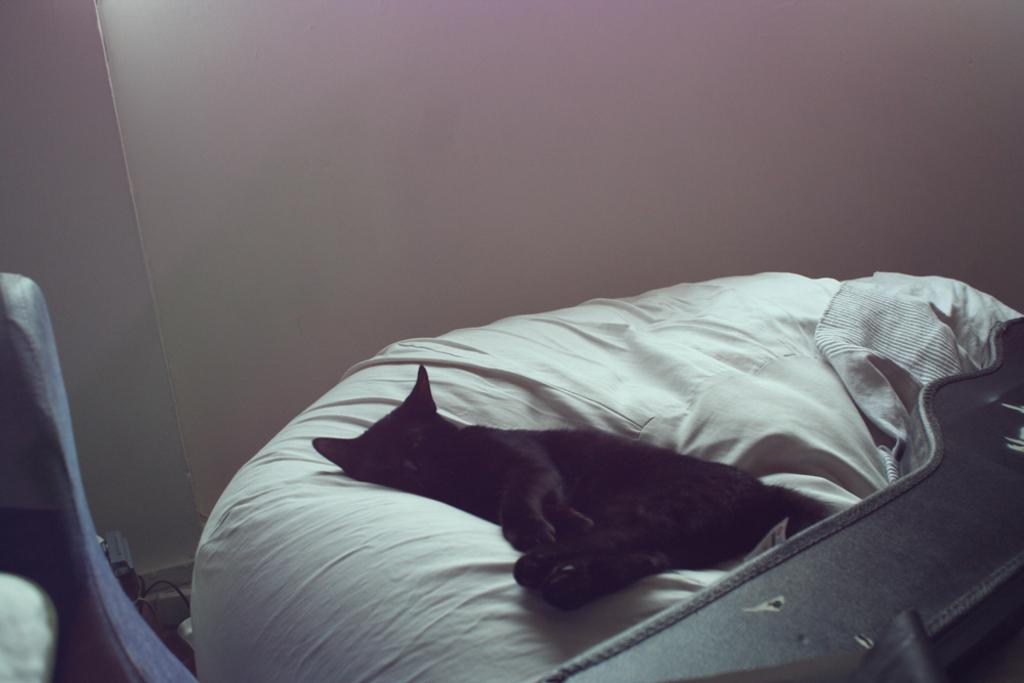What type of animal is in the image? There is a cat in the image. Where is the cat located in the image? The cat is laying on a bed. How many chairs are visible in the image? There are no chairs visible in the image; it only features a cat laying on a bed. What type of riddle can be solved by looking at the image? There is no riddle present in the image, as it only features a cat laying on a bed. 